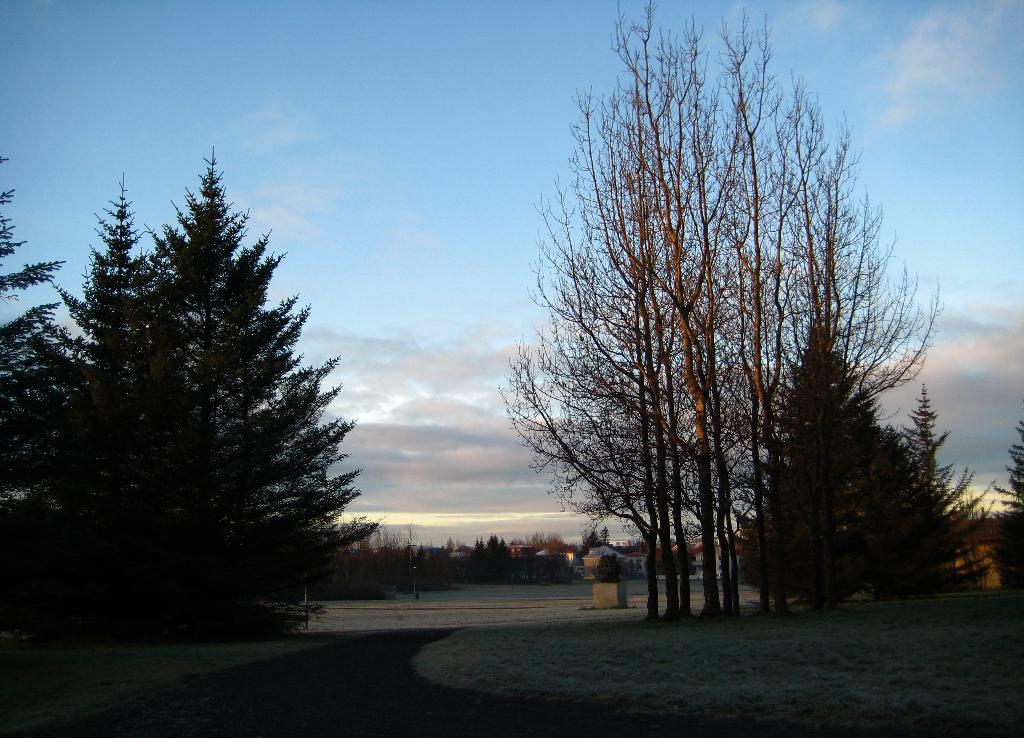What is the main subject of the image? The main subject of the image is an empty road. What can be seen beside the road? There are trees beside the road. Is there any structure visible in the image? Yes, there is a building in the image. What type of garden can be seen in the image? There is no garden present in the image; it features an empty road, trees, and a building. 